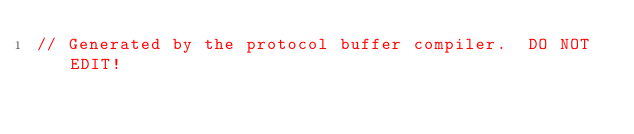Convert code to text. <code><loc_0><loc_0><loc_500><loc_500><_Java_>// Generated by the protocol buffer compiler.  DO NOT EDIT!</code> 